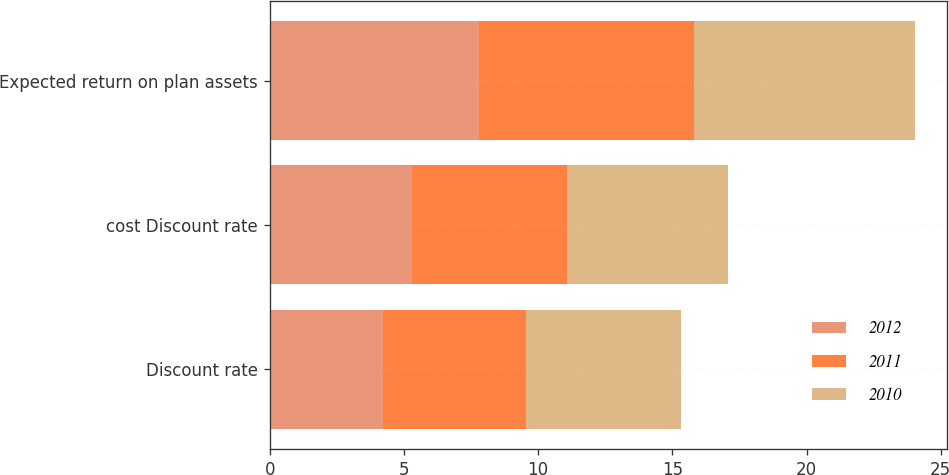Convert chart to OTSL. <chart><loc_0><loc_0><loc_500><loc_500><stacked_bar_chart><ecel><fcel>Discount rate<fcel>cost Discount rate<fcel>Expected return on plan assets<nl><fcel>2012<fcel>4.23<fcel>5.3<fcel>7.8<nl><fcel>2011<fcel>5.3<fcel>5.79<fcel>8<nl><fcel>2010<fcel>5.79<fcel>6<fcel>8.25<nl></chart> 